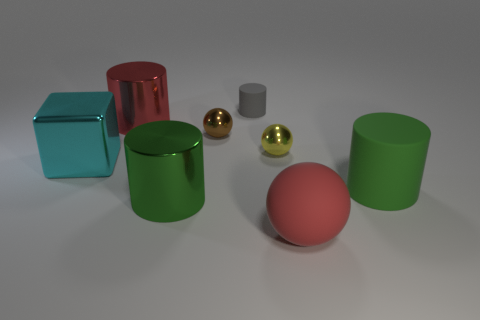Subtract all green blocks. How many green cylinders are left? 2 Subtract 1 balls. How many balls are left? 2 Subtract all gray cylinders. How many cylinders are left? 3 Add 1 yellow spheres. How many objects exist? 9 Subtract all brown cylinders. Subtract all red cubes. How many cylinders are left? 4 Subtract all cubes. How many objects are left? 7 Subtract all large red spheres. Subtract all small metallic objects. How many objects are left? 5 Add 5 tiny gray rubber cylinders. How many tiny gray rubber cylinders are left? 6 Add 4 large blue rubber cylinders. How many large blue rubber cylinders exist? 4 Subtract 0 purple cylinders. How many objects are left? 8 